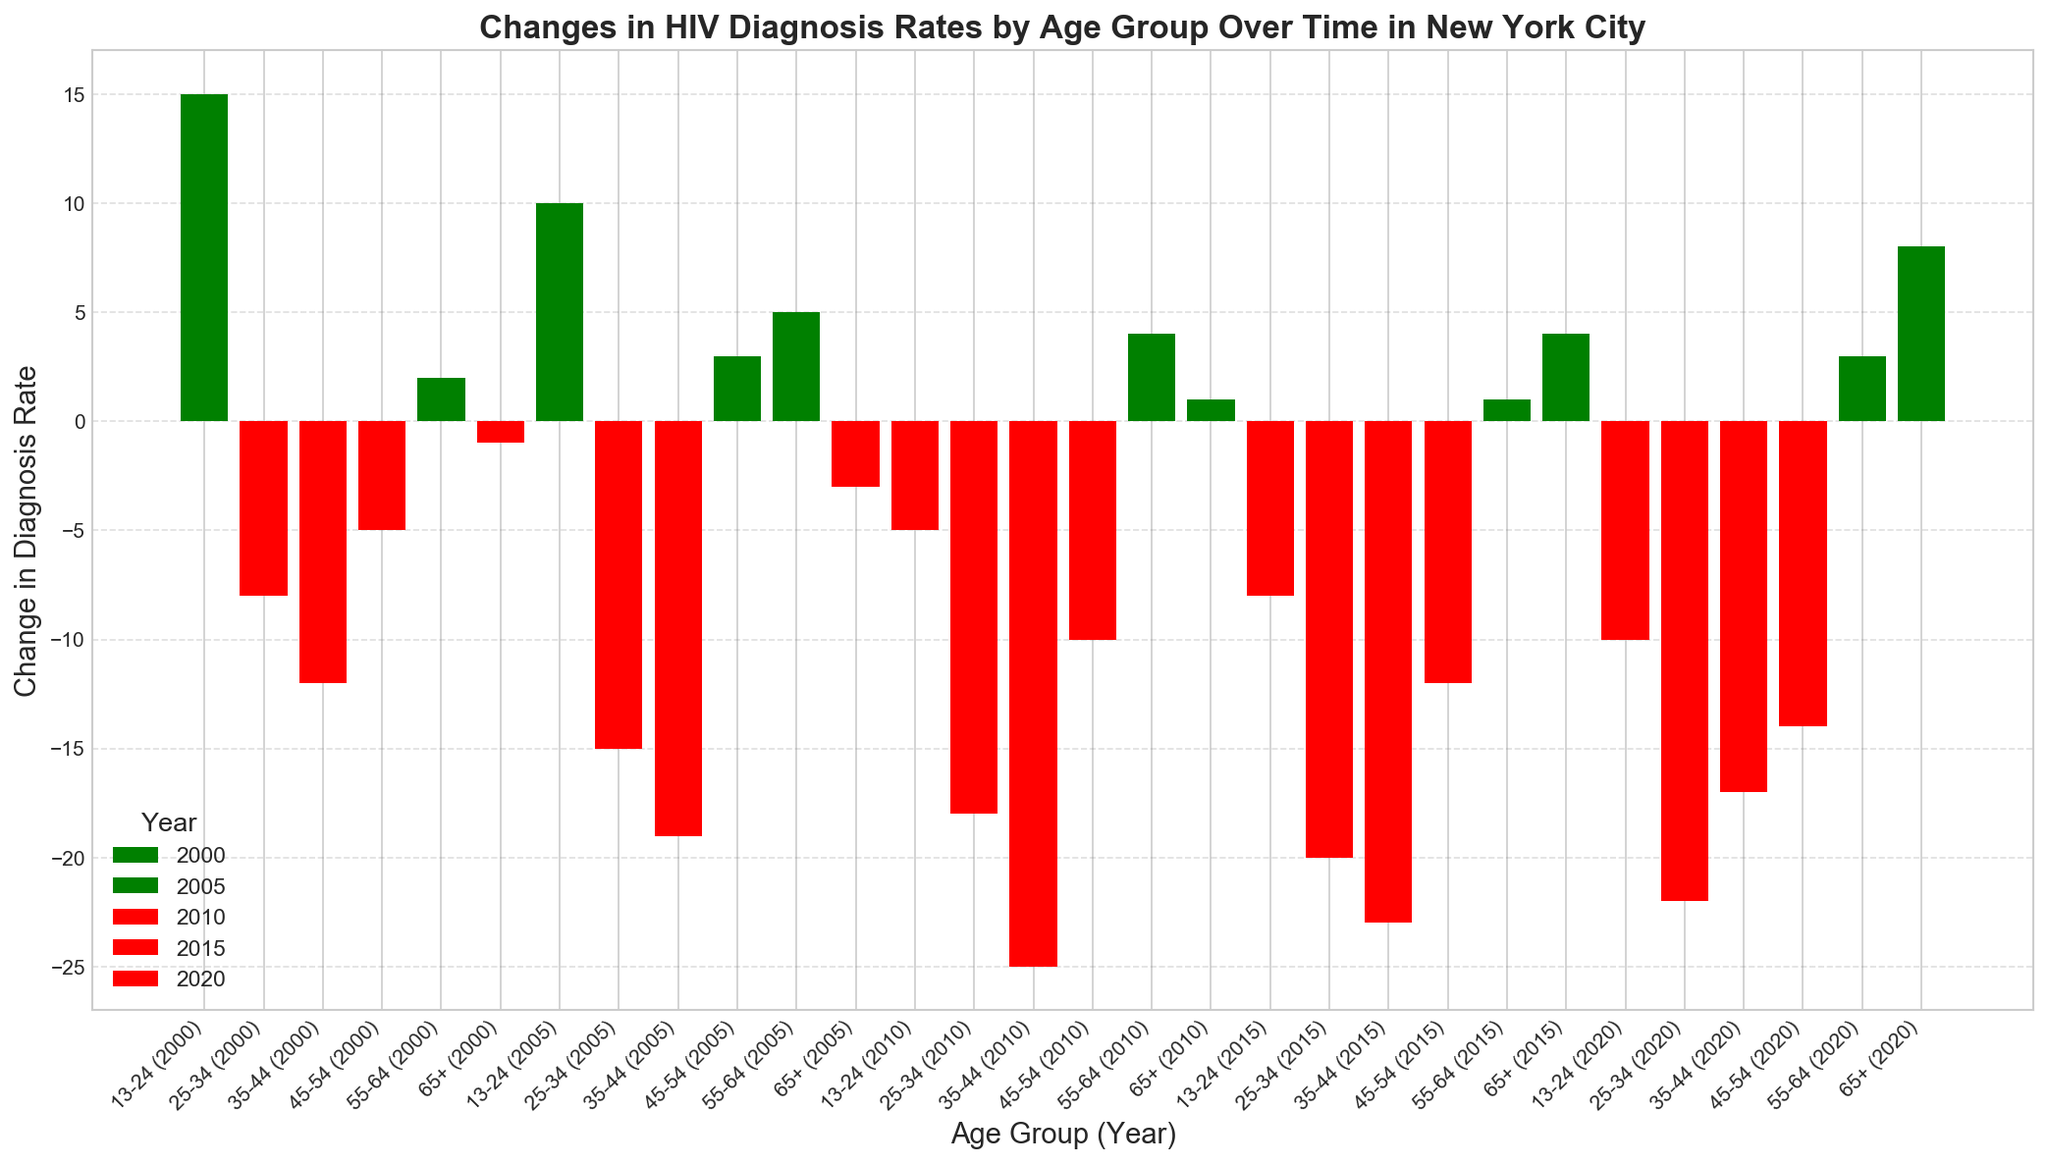Which age group consistently saw a positive change in diagnosis rates over the years? By looking at the color of the bars for each age group across all years, we see that the age group 55-64 consistently has green bars, indicating positive changes.
Answer: 55-64 Which age group experienced the largest decrease in diagnosis rates in 2020? In 2020, the largest negative change (tallest red bar) is for the age group 25-34.
Answer: 25-34 What was the change in diagnosis rates for age group 13-24 from 2000 to 2020? The figure shows 13-24 had a change of +15 in 2000 and -10 in 2020. The difference is -10 - (+15) = -25.
Answer: -25 Which year had the most significant overall reduction in diagnosis rates across all age groups? Adding up all the changes for each year, 2000: +15 -8 -12 -5 +2 -1 = -9; 2005: +10 -15 -19 +3 +5 -3 = -19; 2010: -5 -18 -25 -10 +4 +1 = -53; 2015: -8 -20 -23 -12 +1 +4 = -58; 2020: -10 -22 -17 -14 +3 +8 = -52. The most significant reduction is in 2015.
Answer: 2015 Was there any age group that had a positive change in diagnosis rates in 2010? Checking the figure for 2010, we see green bars for 55-64 and 65+, indicating positive changes.
Answer: Yes Which two age groups experienced an increase in diagnosis rates in 2005? In 2005, the green bars are found for age groups 45-54 and 55-64.
Answer: 45-54, 55-64 Between which years did the age group 25-34 see the most significant decrease in diagnosis rate? Assessing the changes for 25-34: from 2000 (-8) to 2005 (-15) is -7; from 2005 to 2010 (-18) is -3; from 2010 to 2015 (-20) is -2; from 2015 to 2020 (-22) is -2. The most significant drop is from 2000 to 2005.
Answer: 2000 to 2005 How many age groups saw a positive change in diagnosis rates in 2000? In 2000, the positive changes (green bars) are for 13-24 and 55-64. That's two age groups.
Answer: 2 In which year did the age group 45-54 experience the first negative change in diagnosis rate? By examining the bars for 45-54 across 2000, 2005, 2010, 2015, and 2020, the first negative change appears in 2010.
Answer: 2010 